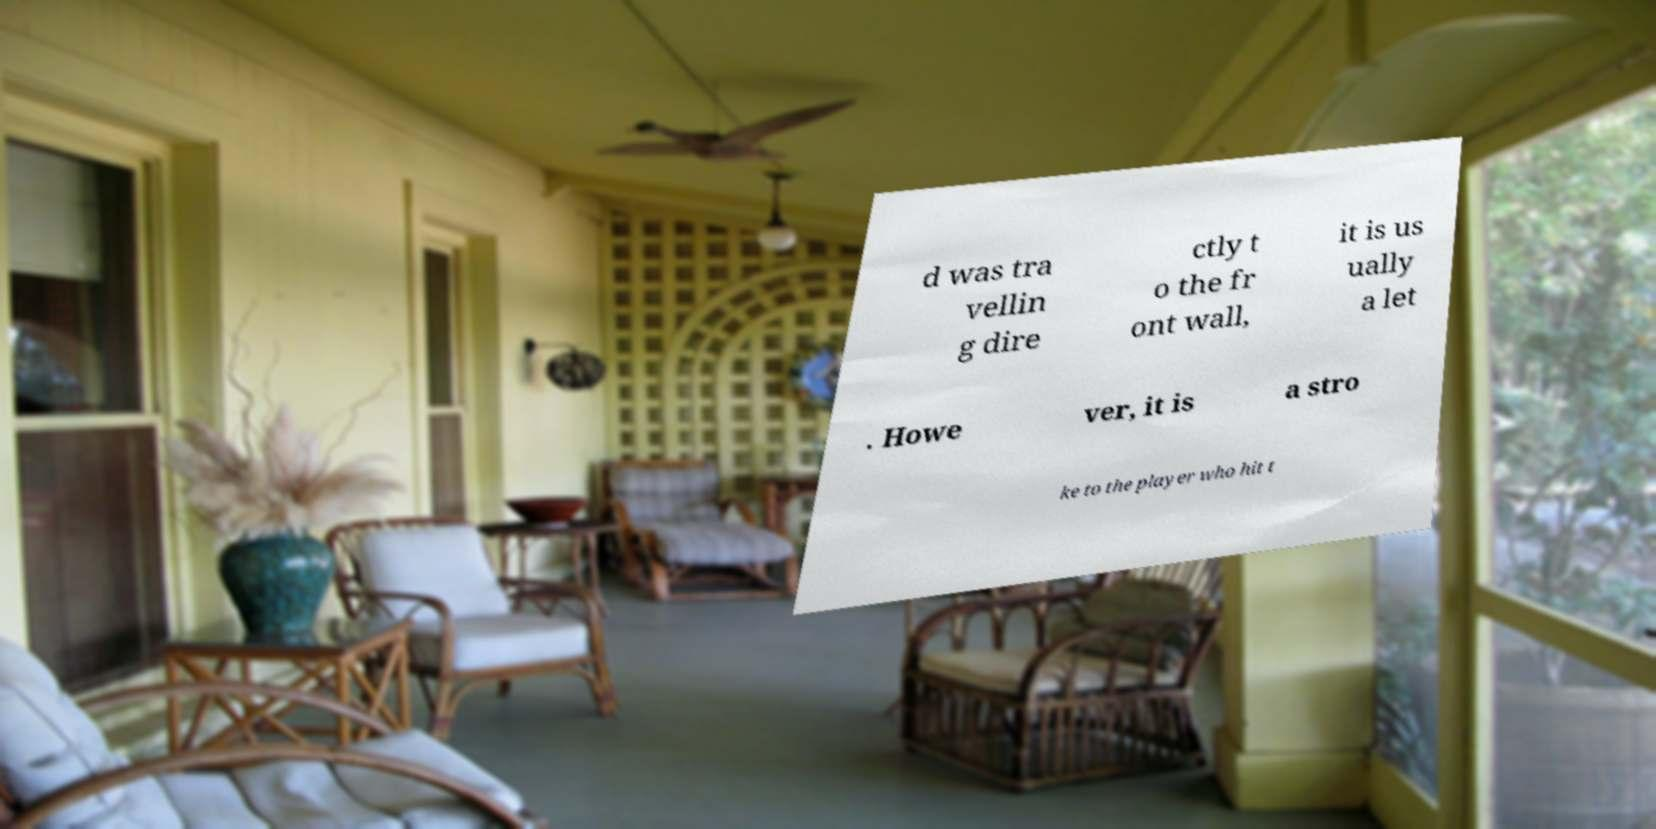Please read and relay the text visible in this image. What does it say? d was tra vellin g dire ctly t o the fr ont wall, it is us ually a let . Howe ver, it is a stro ke to the player who hit t 